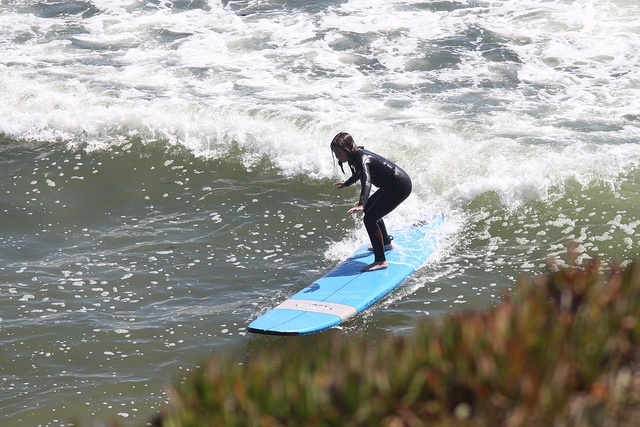Describe the objects in this image and their specific colors. I can see surfboard in white, lightblue, lavender, and gray tones and people in white, black, gray, lightgray, and darkgray tones in this image. 